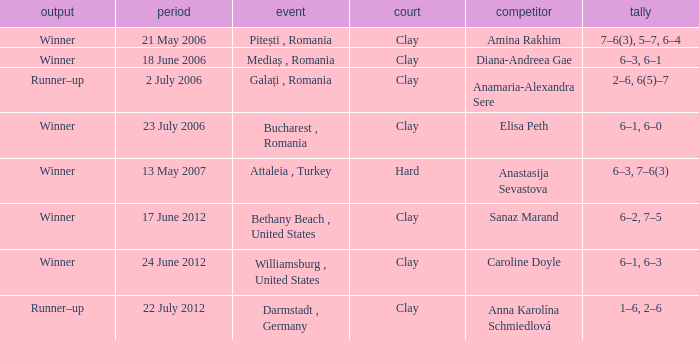What was the score in the match against Sanaz Marand? 6–2, 7–5. 